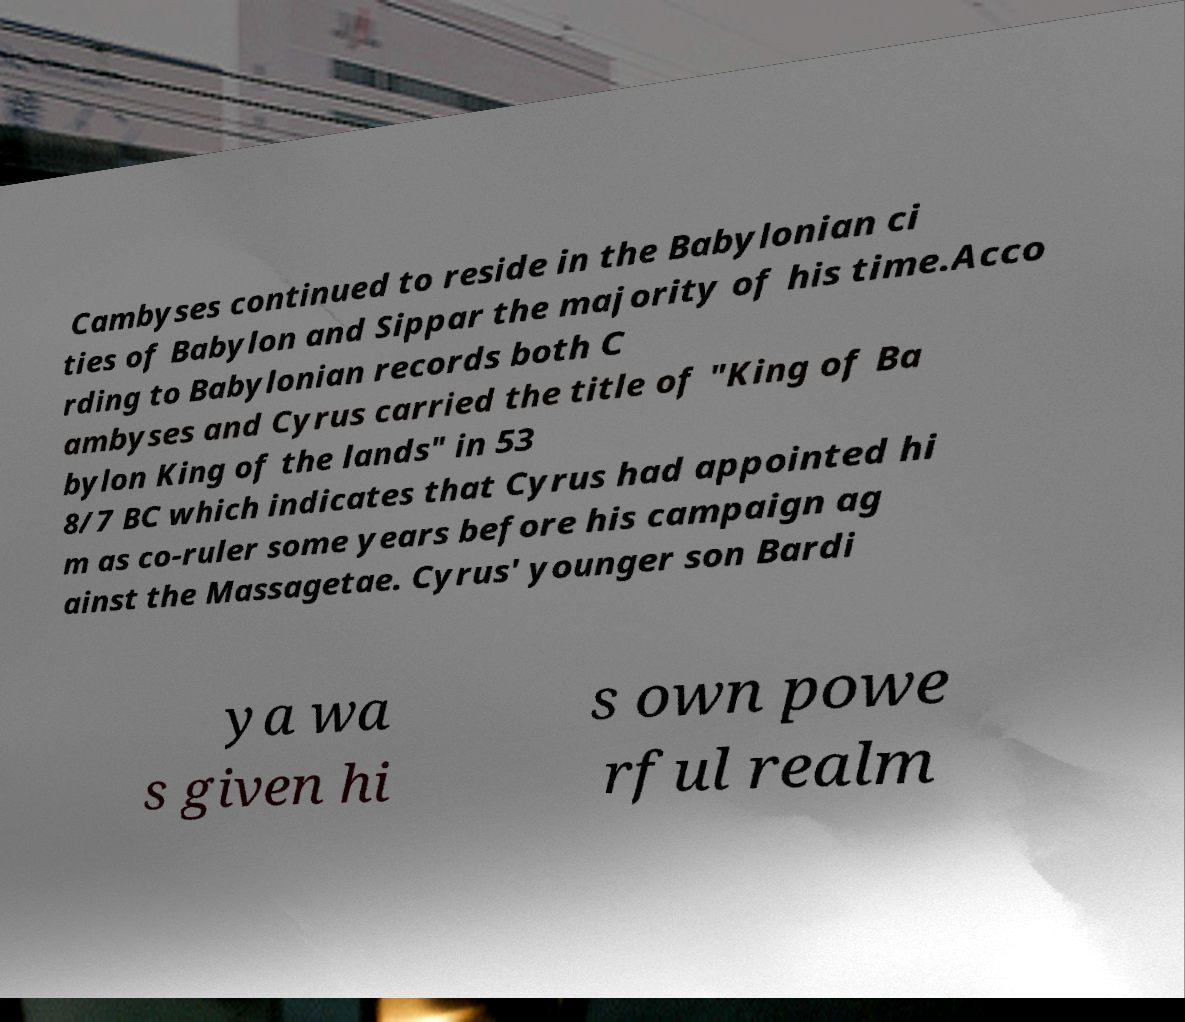What messages or text are displayed in this image? I need them in a readable, typed format. Cambyses continued to reside in the Babylonian ci ties of Babylon and Sippar the majority of his time.Acco rding to Babylonian records both C ambyses and Cyrus carried the title of "King of Ba bylon King of the lands" in 53 8/7 BC which indicates that Cyrus had appointed hi m as co-ruler some years before his campaign ag ainst the Massagetae. Cyrus' younger son Bardi ya wa s given hi s own powe rful realm 